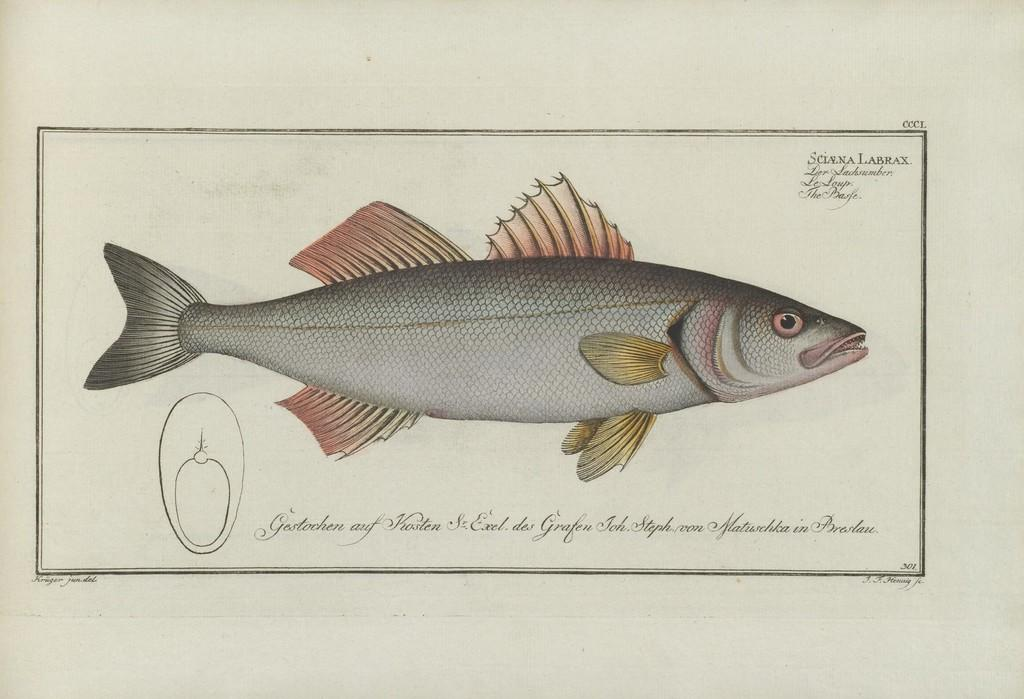What type of animal is in the image? There is a fish in the image. Can you describe the colors of the fish? The fish has brown and light grey colors. What color is the background of the image? The background of the image is white. Is there any text or writing on the image? Yes, there is text or writing on the image. What type of machine is visible in the image? There is no machine present in the image; it features a fish with text or writing on a white background. What time of day is depicted in the image? The image does not depict a specific time of day, as it only shows a fish with text or writing on a white background. 